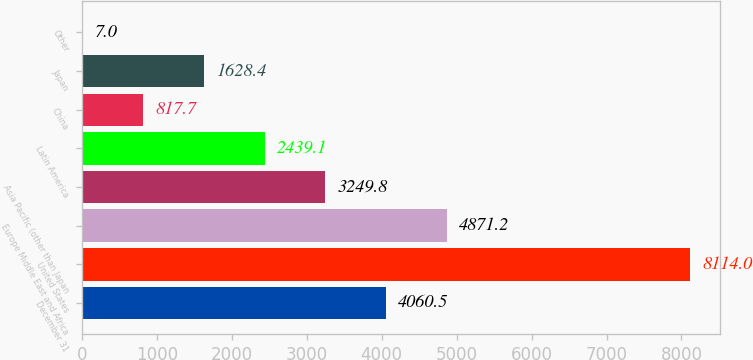<chart> <loc_0><loc_0><loc_500><loc_500><bar_chart><fcel>December 31<fcel>United States<fcel>Europe Middle East and Africa<fcel>Asia Pacific (other than Japan<fcel>Latin America<fcel>China<fcel>Japan<fcel>Other<nl><fcel>4060.5<fcel>8114<fcel>4871.2<fcel>3249.8<fcel>2439.1<fcel>817.7<fcel>1628.4<fcel>7<nl></chart> 